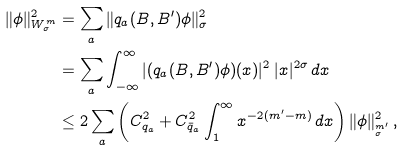<formula> <loc_0><loc_0><loc_500><loc_500>\| \phi \| _ { W _ { \sigma } ^ { m } } ^ { 2 } & = \sum _ { a } \| q _ { a } ( B , B ^ { \prime } ) \phi \| _ { \sigma } ^ { 2 } \\ & = \sum _ { a } \int _ { - \infty } ^ { \infty } | ( q _ { a } ( B , B ^ { \prime } ) \phi ) ( x ) | ^ { 2 } \, | x | ^ { 2 \sigma } \, d x \\ & \leq 2 \sum _ { a } \left ( C _ { q _ { a } } ^ { 2 } + C _ { \bar { q } _ { a } } ^ { 2 } \int _ { 1 } ^ { \infty } x ^ { - 2 ( m ^ { \prime } - m ) } \, d x \right ) \| \phi \| _ { _ { \sigma } ^ { m ^ { \prime } } } ^ { 2 } \, ,</formula> 